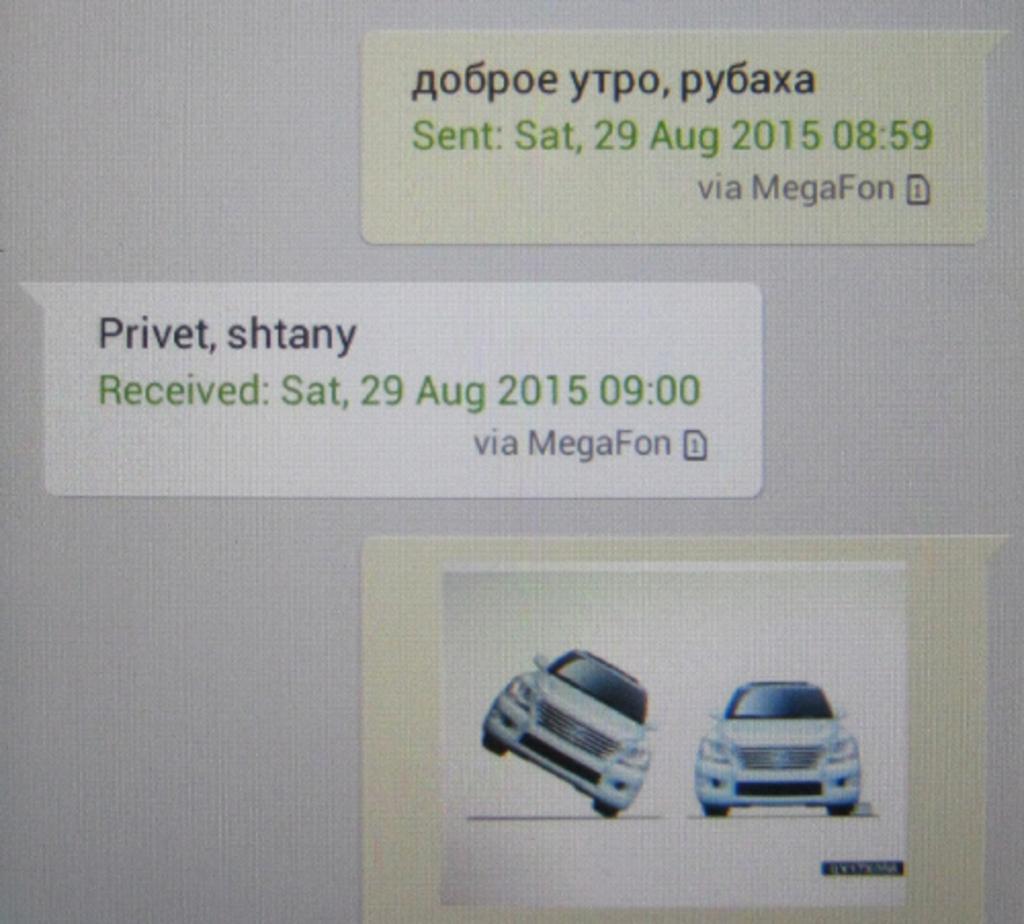Could you give a brief overview of what you see in this image? In this image we can see there are labels. On the label there is some text and an image of two cars. 